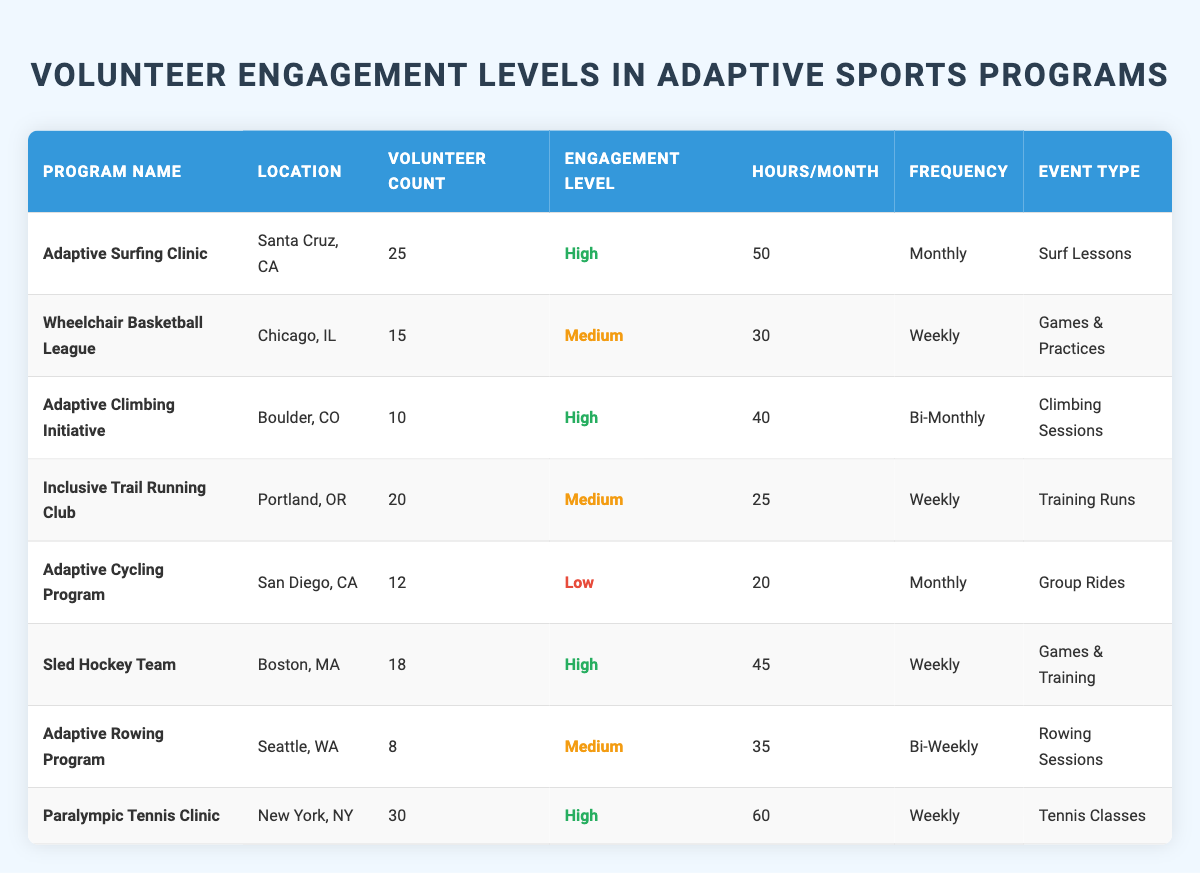How many volunteers are involved in the Adaptive Surfing Clinic? The table shows that the Volunteer Count for the Adaptive Surfing Clinic is 25.
Answer: 25 What is the Engagement Level of the Sled Hockey Team? According to the table, the Engagement Level for the Sled Hockey Team is "High."
Answer: High Which program has the highest number of volunteer hours committed per month? Among the programs listed, the Paralympic Tennis Clinic has the highest at 60 hours per month.
Answer: 60 How many programs have a Medium Engagement Level? The table lists three programs (Wheelchair Basketball League, Inclusive Trail Running Club, Adaptive Rowing Program) with a Medium Engagement Level.
Answer: 3 What is the total number of volunteers across all programs? The Volunteer Counts are 25, 15, 10, 20, 12, 18, 8, and 30. Their sum is 25 + 15 + 10 + 20 + 12 + 18 + 8 + 30 = 138.
Answer: 138 Is there any program located in Boston, MA? Yes, the Sled Hockey Team is located in Boston, MA, as indicated in the table.
Answer: Yes Which program has the lowest volunteer count and what is its Engagement Level? The Adaptive Cycling Program has the lowest Volunteer Count of 12 with a Low Engagement Level.
Answer: Low What is the average number of volunteer hours committed per month for programs with a High Engagement Level? The high engagement programs are Adaptive Surfing Clinic (50 hours), Adaptive Climbing Initiative (40 hours), Sled Hockey Team (45 hours), and Paralympic Tennis Clinic (60 hours). Their total is 50 + 40 + 45 + 60 = 195. The average is 195/4 = 48.75.
Answer: 48.75 Which program has the most frequent events and what is their type? The Wheelchair Basketball League has weekly events, which are Games & Practices.
Answer: Weekly, Games & Practices Does the Adaptive Cycling Program have a High Engagement Level? No, the Adaptive Cycling Program is noted as having a Low Engagement Level in the table.
Answer: No 